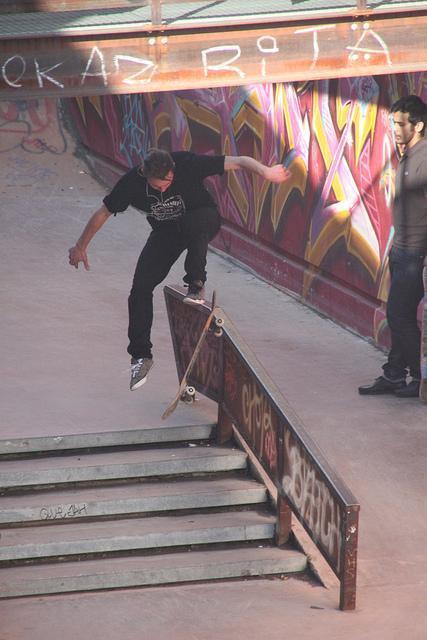How many steps is there?
Give a very brief answer. 5. How many people are in the photo?
Give a very brief answer. 2. 